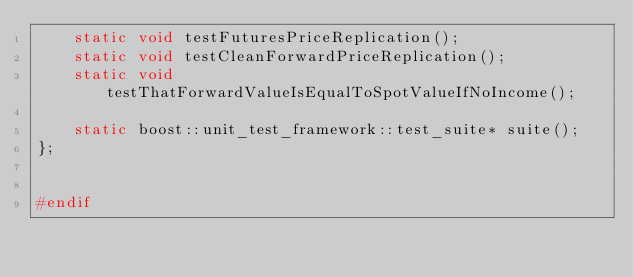<code> <loc_0><loc_0><loc_500><loc_500><_C++_>    static void testFuturesPriceReplication();
    static void testCleanForwardPriceReplication();
    static void testThatForwardValueIsEqualToSpotValueIfNoIncome();

    static boost::unit_test_framework::test_suite* suite();
};


#endif</code> 